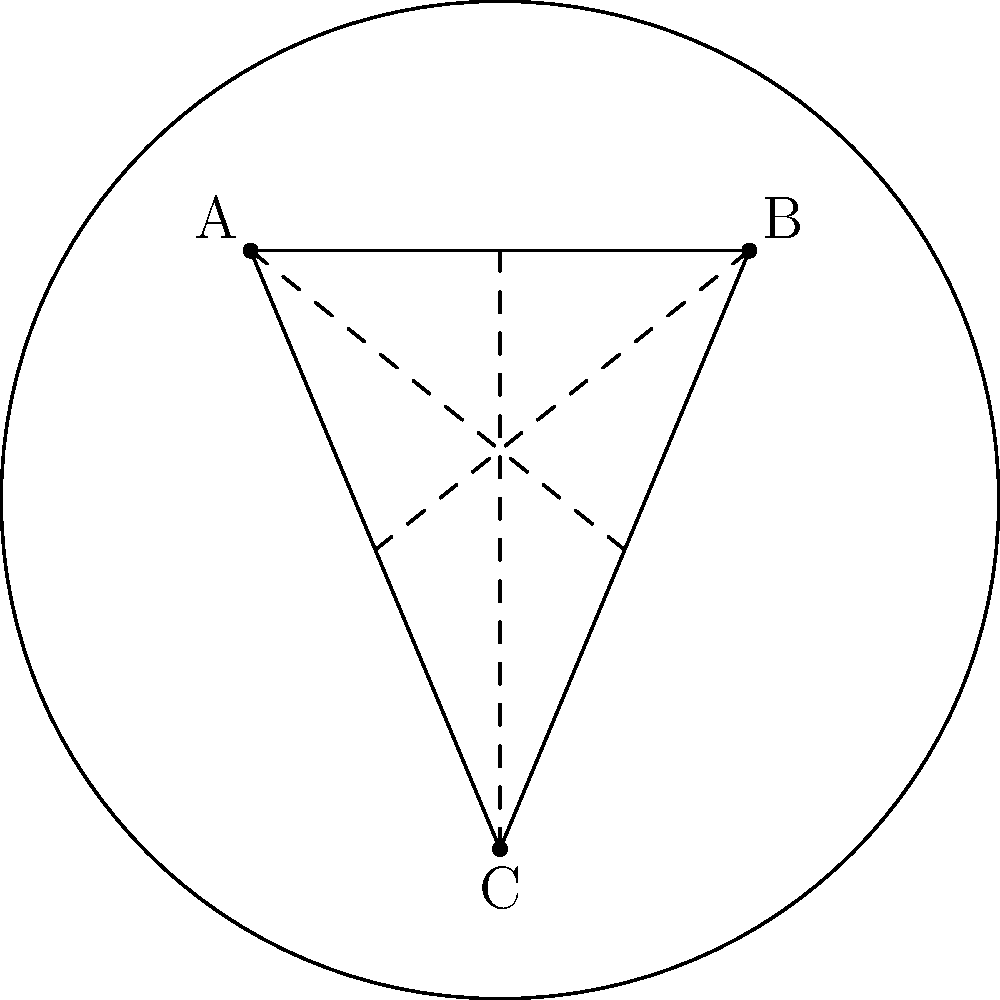In a hyperbolic plane represented by the Poincaré disk model, triangle ABC is shown. If the sum of the interior angles of this triangle is 150°, what is the area of the triangle in terms of π and R (where R is the radius of curvature of the hyperbolic plane)? To solve this problem, we'll use the following steps:

1) In hyperbolic geometry, the area of a triangle is related to its angle defect. The formula is:

   Area = $(π - (A + B + C))R^2$

   Where A, B, and C are the angles of the triangle, and R is the radius of curvature.

2) We're given that the sum of the interior angles is 150°. Let's convert this to radians:

   $150° * (π/180°) = 5π/6$ radians

3) Now we can calculate the angle defect:

   Angle defect = $π - (A + B + C) = π - 5π/6 = π/6$

4) Substituting this into our area formula:

   Area = $(π/6)R^2$

5) This is our final answer. The area of the triangle is $(π/6)R^2$.

This result demonstrates how in hyperbolic geometry, unlike in Euclidean geometry, the area of a triangle is determined by its angle defect and the curvature of the space (represented by R).
Answer: $(π/6)R^2$ 